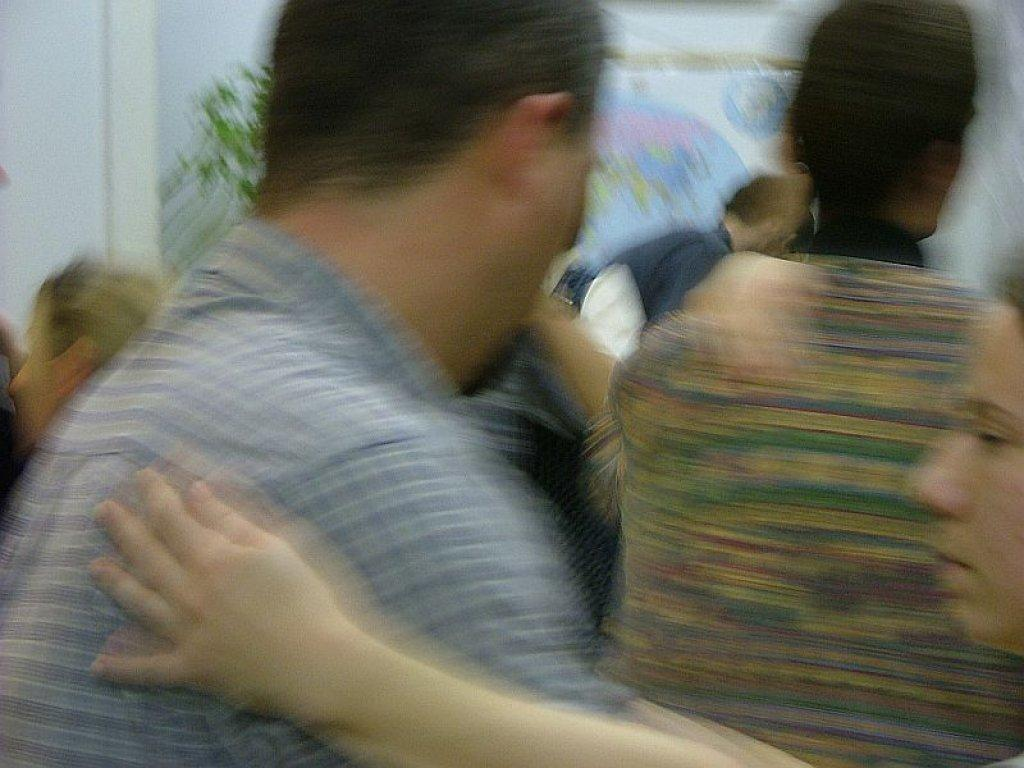What can be seen in the image that is not in focus? There are blurred persons standing in the image. What is visible in the background of the image? There is a plant in the background of the image. What color of ink is being used by the orange in the image? There is no orange or ink present in the image; it features blurred persons and a plant in the background. 